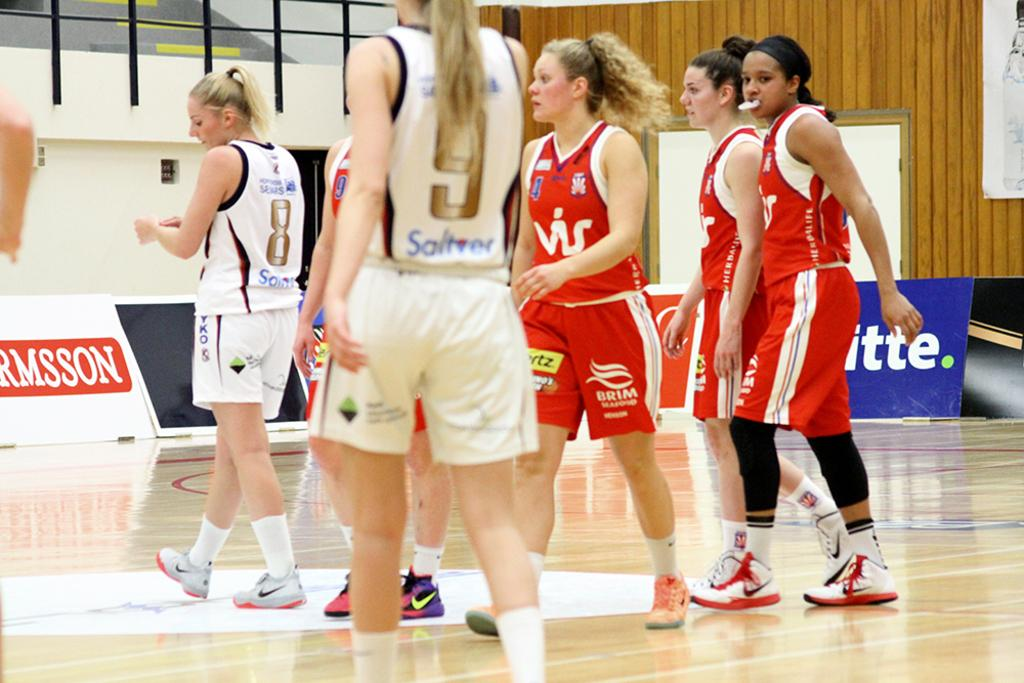<image>
Render a clear and concise summary of the photo. Two groups of girls in uniforms, the red uniforms say Brim on the shorts 